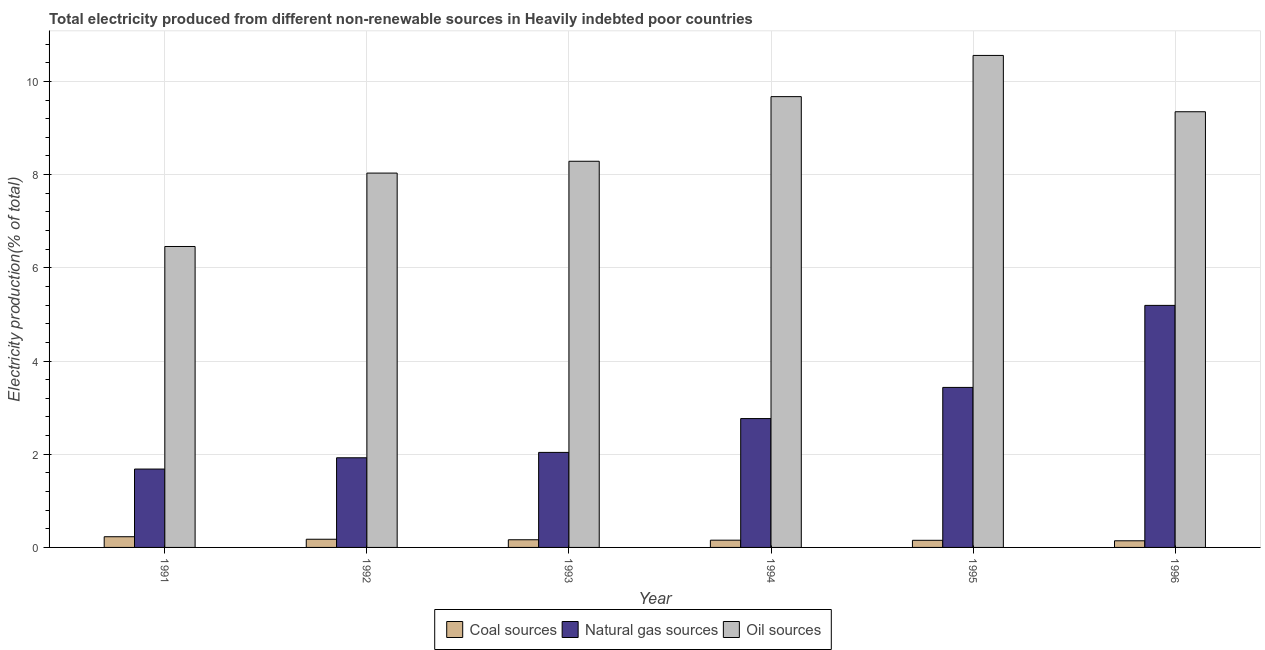Are the number of bars per tick equal to the number of legend labels?
Your answer should be very brief. Yes. Are the number of bars on each tick of the X-axis equal?
Offer a very short reply. Yes. How many bars are there on the 5th tick from the right?
Make the answer very short. 3. What is the label of the 6th group of bars from the left?
Ensure brevity in your answer.  1996. What is the percentage of electricity produced by natural gas in 1996?
Give a very brief answer. 5.19. Across all years, what is the maximum percentage of electricity produced by coal?
Ensure brevity in your answer.  0.23. Across all years, what is the minimum percentage of electricity produced by coal?
Offer a terse response. 0.14. In which year was the percentage of electricity produced by oil sources minimum?
Keep it short and to the point. 1991. What is the total percentage of electricity produced by natural gas in the graph?
Make the answer very short. 17.04. What is the difference between the percentage of electricity produced by natural gas in 1993 and that in 1996?
Your response must be concise. -3.15. What is the difference between the percentage of electricity produced by natural gas in 1993 and the percentage of electricity produced by oil sources in 1995?
Keep it short and to the point. -1.39. What is the average percentage of electricity produced by natural gas per year?
Your response must be concise. 2.84. In the year 1996, what is the difference between the percentage of electricity produced by natural gas and percentage of electricity produced by oil sources?
Offer a terse response. 0. In how many years, is the percentage of electricity produced by natural gas greater than 4.8 %?
Your answer should be compact. 1. What is the ratio of the percentage of electricity produced by coal in 1991 to that in 1996?
Offer a very short reply. 1.61. Is the difference between the percentage of electricity produced by coal in 1991 and 1995 greater than the difference between the percentage of electricity produced by natural gas in 1991 and 1995?
Provide a succinct answer. No. What is the difference between the highest and the second highest percentage of electricity produced by oil sources?
Provide a short and direct response. 0.88. What is the difference between the highest and the lowest percentage of electricity produced by oil sources?
Give a very brief answer. 4.1. What does the 2nd bar from the left in 1992 represents?
Offer a terse response. Natural gas sources. What does the 3rd bar from the right in 1993 represents?
Keep it short and to the point. Coal sources. Is it the case that in every year, the sum of the percentage of electricity produced by coal and percentage of electricity produced by natural gas is greater than the percentage of electricity produced by oil sources?
Make the answer very short. No. How many bars are there?
Make the answer very short. 18. Are the values on the major ticks of Y-axis written in scientific E-notation?
Make the answer very short. No. Does the graph contain any zero values?
Offer a very short reply. No. Does the graph contain grids?
Your answer should be compact. Yes. Where does the legend appear in the graph?
Give a very brief answer. Bottom center. What is the title of the graph?
Offer a terse response. Total electricity produced from different non-renewable sources in Heavily indebted poor countries. What is the label or title of the X-axis?
Your response must be concise. Year. What is the label or title of the Y-axis?
Ensure brevity in your answer.  Electricity production(% of total). What is the Electricity production(% of total) in Coal sources in 1991?
Provide a short and direct response. 0.23. What is the Electricity production(% of total) of Natural gas sources in 1991?
Make the answer very short. 1.68. What is the Electricity production(% of total) in Oil sources in 1991?
Offer a terse response. 6.46. What is the Electricity production(% of total) of Coal sources in 1992?
Ensure brevity in your answer.  0.18. What is the Electricity production(% of total) in Natural gas sources in 1992?
Offer a very short reply. 1.92. What is the Electricity production(% of total) of Oil sources in 1992?
Provide a short and direct response. 8.03. What is the Electricity production(% of total) of Coal sources in 1993?
Make the answer very short. 0.16. What is the Electricity production(% of total) of Natural gas sources in 1993?
Offer a very short reply. 2.04. What is the Electricity production(% of total) of Oil sources in 1993?
Make the answer very short. 8.29. What is the Electricity production(% of total) in Coal sources in 1994?
Your answer should be very brief. 0.16. What is the Electricity production(% of total) in Natural gas sources in 1994?
Ensure brevity in your answer.  2.76. What is the Electricity production(% of total) of Oil sources in 1994?
Ensure brevity in your answer.  9.67. What is the Electricity production(% of total) in Coal sources in 1995?
Your answer should be very brief. 0.15. What is the Electricity production(% of total) in Natural gas sources in 1995?
Provide a short and direct response. 3.43. What is the Electricity production(% of total) of Oil sources in 1995?
Ensure brevity in your answer.  10.56. What is the Electricity production(% of total) in Coal sources in 1996?
Provide a short and direct response. 0.14. What is the Electricity production(% of total) of Natural gas sources in 1996?
Your answer should be very brief. 5.19. What is the Electricity production(% of total) of Oil sources in 1996?
Keep it short and to the point. 9.35. Across all years, what is the maximum Electricity production(% of total) in Coal sources?
Make the answer very short. 0.23. Across all years, what is the maximum Electricity production(% of total) of Natural gas sources?
Offer a terse response. 5.19. Across all years, what is the maximum Electricity production(% of total) in Oil sources?
Make the answer very short. 10.56. Across all years, what is the minimum Electricity production(% of total) in Coal sources?
Your response must be concise. 0.14. Across all years, what is the minimum Electricity production(% of total) in Natural gas sources?
Your answer should be very brief. 1.68. Across all years, what is the minimum Electricity production(% of total) in Oil sources?
Provide a short and direct response. 6.46. What is the total Electricity production(% of total) in Coal sources in the graph?
Make the answer very short. 1.02. What is the total Electricity production(% of total) of Natural gas sources in the graph?
Your answer should be compact. 17.04. What is the total Electricity production(% of total) of Oil sources in the graph?
Provide a short and direct response. 52.35. What is the difference between the Electricity production(% of total) in Coal sources in 1991 and that in 1992?
Give a very brief answer. 0.05. What is the difference between the Electricity production(% of total) in Natural gas sources in 1991 and that in 1992?
Provide a succinct answer. -0.24. What is the difference between the Electricity production(% of total) of Oil sources in 1991 and that in 1992?
Offer a very short reply. -1.57. What is the difference between the Electricity production(% of total) of Coal sources in 1991 and that in 1993?
Your response must be concise. 0.07. What is the difference between the Electricity production(% of total) in Natural gas sources in 1991 and that in 1993?
Provide a short and direct response. -0.36. What is the difference between the Electricity production(% of total) of Oil sources in 1991 and that in 1993?
Offer a terse response. -1.83. What is the difference between the Electricity production(% of total) in Coal sources in 1991 and that in 1994?
Offer a very short reply. 0.07. What is the difference between the Electricity production(% of total) in Natural gas sources in 1991 and that in 1994?
Provide a short and direct response. -1.08. What is the difference between the Electricity production(% of total) of Oil sources in 1991 and that in 1994?
Your response must be concise. -3.22. What is the difference between the Electricity production(% of total) in Coal sources in 1991 and that in 1995?
Provide a short and direct response. 0.08. What is the difference between the Electricity production(% of total) of Natural gas sources in 1991 and that in 1995?
Make the answer very short. -1.75. What is the difference between the Electricity production(% of total) in Oil sources in 1991 and that in 1995?
Offer a terse response. -4.1. What is the difference between the Electricity production(% of total) in Coal sources in 1991 and that in 1996?
Keep it short and to the point. 0.09. What is the difference between the Electricity production(% of total) in Natural gas sources in 1991 and that in 1996?
Give a very brief answer. -3.51. What is the difference between the Electricity production(% of total) of Oil sources in 1991 and that in 1996?
Offer a very short reply. -2.89. What is the difference between the Electricity production(% of total) in Coal sources in 1992 and that in 1993?
Provide a short and direct response. 0.01. What is the difference between the Electricity production(% of total) of Natural gas sources in 1992 and that in 1993?
Provide a succinct answer. -0.12. What is the difference between the Electricity production(% of total) in Oil sources in 1992 and that in 1993?
Make the answer very short. -0.25. What is the difference between the Electricity production(% of total) of Coal sources in 1992 and that in 1994?
Your answer should be compact. 0.02. What is the difference between the Electricity production(% of total) of Natural gas sources in 1992 and that in 1994?
Ensure brevity in your answer.  -0.84. What is the difference between the Electricity production(% of total) in Oil sources in 1992 and that in 1994?
Your response must be concise. -1.64. What is the difference between the Electricity production(% of total) in Coal sources in 1992 and that in 1995?
Your response must be concise. 0.02. What is the difference between the Electricity production(% of total) of Natural gas sources in 1992 and that in 1995?
Your response must be concise. -1.51. What is the difference between the Electricity production(% of total) in Oil sources in 1992 and that in 1995?
Your answer should be compact. -2.52. What is the difference between the Electricity production(% of total) in Coal sources in 1992 and that in 1996?
Ensure brevity in your answer.  0.03. What is the difference between the Electricity production(% of total) in Natural gas sources in 1992 and that in 1996?
Offer a terse response. -3.27. What is the difference between the Electricity production(% of total) in Oil sources in 1992 and that in 1996?
Your response must be concise. -1.32. What is the difference between the Electricity production(% of total) of Coal sources in 1993 and that in 1994?
Your answer should be compact. 0.01. What is the difference between the Electricity production(% of total) in Natural gas sources in 1993 and that in 1994?
Offer a very short reply. -0.73. What is the difference between the Electricity production(% of total) of Oil sources in 1993 and that in 1994?
Give a very brief answer. -1.39. What is the difference between the Electricity production(% of total) in Coal sources in 1993 and that in 1995?
Offer a terse response. 0.01. What is the difference between the Electricity production(% of total) of Natural gas sources in 1993 and that in 1995?
Make the answer very short. -1.39. What is the difference between the Electricity production(% of total) in Oil sources in 1993 and that in 1995?
Your answer should be compact. -2.27. What is the difference between the Electricity production(% of total) in Coal sources in 1993 and that in 1996?
Offer a very short reply. 0.02. What is the difference between the Electricity production(% of total) in Natural gas sources in 1993 and that in 1996?
Keep it short and to the point. -3.15. What is the difference between the Electricity production(% of total) in Oil sources in 1993 and that in 1996?
Offer a very short reply. -1.06. What is the difference between the Electricity production(% of total) of Coal sources in 1994 and that in 1995?
Keep it short and to the point. 0. What is the difference between the Electricity production(% of total) in Natural gas sources in 1994 and that in 1995?
Keep it short and to the point. -0.67. What is the difference between the Electricity production(% of total) in Oil sources in 1994 and that in 1995?
Offer a very short reply. -0.88. What is the difference between the Electricity production(% of total) in Coal sources in 1994 and that in 1996?
Make the answer very short. 0.01. What is the difference between the Electricity production(% of total) in Natural gas sources in 1994 and that in 1996?
Provide a short and direct response. -2.43. What is the difference between the Electricity production(% of total) of Oil sources in 1994 and that in 1996?
Your answer should be very brief. 0.32. What is the difference between the Electricity production(% of total) in Coal sources in 1995 and that in 1996?
Ensure brevity in your answer.  0.01. What is the difference between the Electricity production(% of total) in Natural gas sources in 1995 and that in 1996?
Give a very brief answer. -1.76. What is the difference between the Electricity production(% of total) in Oil sources in 1995 and that in 1996?
Provide a succinct answer. 1.21. What is the difference between the Electricity production(% of total) in Coal sources in 1991 and the Electricity production(% of total) in Natural gas sources in 1992?
Your answer should be very brief. -1.69. What is the difference between the Electricity production(% of total) in Coal sources in 1991 and the Electricity production(% of total) in Oil sources in 1992?
Make the answer very short. -7.8. What is the difference between the Electricity production(% of total) in Natural gas sources in 1991 and the Electricity production(% of total) in Oil sources in 1992?
Keep it short and to the point. -6.35. What is the difference between the Electricity production(% of total) of Coal sources in 1991 and the Electricity production(% of total) of Natural gas sources in 1993?
Keep it short and to the point. -1.81. What is the difference between the Electricity production(% of total) in Coal sources in 1991 and the Electricity production(% of total) in Oil sources in 1993?
Provide a short and direct response. -8.06. What is the difference between the Electricity production(% of total) in Natural gas sources in 1991 and the Electricity production(% of total) in Oil sources in 1993?
Make the answer very short. -6.6. What is the difference between the Electricity production(% of total) in Coal sources in 1991 and the Electricity production(% of total) in Natural gas sources in 1994?
Provide a short and direct response. -2.54. What is the difference between the Electricity production(% of total) in Coal sources in 1991 and the Electricity production(% of total) in Oil sources in 1994?
Provide a succinct answer. -9.44. What is the difference between the Electricity production(% of total) in Natural gas sources in 1991 and the Electricity production(% of total) in Oil sources in 1994?
Offer a terse response. -7.99. What is the difference between the Electricity production(% of total) of Coal sources in 1991 and the Electricity production(% of total) of Natural gas sources in 1995?
Make the answer very short. -3.2. What is the difference between the Electricity production(% of total) in Coal sources in 1991 and the Electricity production(% of total) in Oil sources in 1995?
Your answer should be compact. -10.33. What is the difference between the Electricity production(% of total) of Natural gas sources in 1991 and the Electricity production(% of total) of Oil sources in 1995?
Provide a succinct answer. -8.88. What is the difference between the Electricity production(% of total) of Coal sources in 1991 and the Electricity production(% of total) of Natural gas sources in 1996?
Your answer should be very brief. -4.96. What is the difference between the Electricity production(% of total) of Coal sources in 1991 and the Electricity production(% of total) of Oil sources in 1996?
Give a very brief answer. -9.12. What is the difference between the Electricity production(% of total) of Natural gas sources in 1991 and the Electricity production(% of total) of Oil sources in 1996?
Offer a terse response. -7.67. What is the difference between the Electricity production(% of total) in Coal sources in 1992 and the Electricity production(% of total) in Natural gas sources in 1993?
Keep it short and to the point. -1.86. What is the difference between the Electricity production(% of total) in Coal sources in 1992 and the Electricity production(% of total) in Oil sources in 1993?
Make the answer very short. -8.11. What is the difference between the Electricity production(% of total) in Natural gas sources in 1992 and the Electricity production(% of total) in Oil sources in 1993?
Keep it short and to the point. -6.36. What is the difference between the Electricity production(% of total) of Coal sources in 1992 and the Electricity production(% of total) of Natural gas sources in 1994?
Make the answer very short. -2.59. What is the difference between the Electricity production(% of total) of Coal sources in 1992 and the Electricity production(% of total) of Oil sources in 1994?
Offer a very short reply. -9.5. What is the difference between the Electricity production(% of total) in Natural gas sources in 1992 and the Electricity production(% of total) in Oil sources in 1994?
Offer a very short reply. -7.75. What is the difference between the Electricity production(% of total) of Coal sources in 1992 and the Electricity production(% of total) of Natural gas sources in 1995?
Make the answer very short. -3.26. What is the difference between the Electricity production(% of total) in Coal sources in 1992 and the Electricity production(% of total) in Oil sources in 1995?
Provide a succinct answer. -10.38. What is the difference between the Electricity production(% of total) of Natural gas sources in 1992 and the Electricity production(% of total) of Oil sources in 1995?
Offer a terse response. -8.63. What is the difference between the Electricity production(% of total) in Coal sources in 1992 and the Electricity production(% of total) in Natural gas sources in 1996?
Keep it short and to the point. -5.02. What is the difference between the Electricity production(% of total) of Coal sources in 1992 and the Electricity production(% of total) of Oil sources in 1996?
Ensure brevity in your answer.  -9.17. What is the difference between the Electricity production(% of total) of Natural gas sources in 1992 and the Electricity production(% of total) of Oil sources in 1996?
Your answer should be very brief. -7.42. What is the difference between the Electricity production(% of total) in Coal sources in 1993 and the Electricity production(% of total) in Natural gas sources in 1994?
Offer a very short reply. -2.6. What is the difference between the Electricity production(% of total) of Coal sources in 1993 and the Electricity production(% of total) of Oil sources in 1994?
Ensure brevity in your answer.  -9.51. What is the difference between the Electricity production(% of total) in Natural gas sources in 1993 and the Electricity production(% of total) in Oil sources in 1994?
Keep it short and to the point. -7.63. What is the difference between the Electricity production(% of total) in Coal sources in 1993 and the Electricity production(% of total) in Natural gas sources in 1995?
Provide a short and direct response. -3.27. What is the difference between the Electricity production(% of total) in Coal sources in 1993 and the Electricity production(% of total) in Oil sources in 1995?
Your response must be concise. -10.39. What is the difference between the Electricity production(% of total) of Natural gas sources in 1993 and the Electricity production(% of total) of Oil sources in 1995?
Give a very brief answer. -8.52. What is the difference between the Electricity production(% of total) of Coal sources in 1993 and the Electricity production(% of total) of Natural gas sources in 1996?
Give a very brief answer. -5.03. What is the difference between the Electricity production(% of total) of Coal sources in 1993 and the Electricity production(% of total) of Oil sources in 1996?
Provide a succinct answer. -9.18. What is the difference between the Electricity production(% of total) of Natural gas sources in 1993 and the Electricity production(% of total) of Oil sources in 1996?
Offer a terse response. -7.31. What is the difference between the Electricity production(% of total) in Coal sources in 1994 and the Electricity production(% of total) in Natural gas sources in 1995?
Ensure brevity in your answer.  -3.28. What is the difference between the Electricity production(% of total) in Coal sources in 1994 and the Electricity production(% of total) in Oil sources in 1995?
Give a very brief answer. -10.4. What is the difference between the Electricity production(% of total) of Natural gas sources in 1994 and the Electricity production(% of total) of Oil sources in 1995?
Make the answer very short. -7.79. What is the difference between the Electricity production(% of total) in Coal sources in 1994 and the Electricity production(% of total) in Natural gas sources in 1996?
Provide a succinct answer. -5.04. What is the difference between the Electricity production(% of total) of Coal sources in 1994 and the Electricity production(% of total) of Oil sources in 1996?
Ensure brevity in your answer.  -9.19. What is the difference between the Electricity production(% of total) of Natural gas sources in 1994 and the Electricity production(% of total) of Oil sources in 1996?
Offer a very short reply. -6.58. What is the difference between the Electricity production(% of total) in Coal sources in 1995 and the Electricity production(% of total) in Natural gas sources in 1996?
Your answer should be very brief. -5.04. What is the difference between the Electricity production(% of total) in Coal sources in 1995 and the Electricity production(% of total) in Oil sources in 1996?
Provide a short and direct response. -9.2. What is the difference between the Electricity production(% of total) in Natural gas sources in 1995 and the Electricity production(% of total) in Oil sources in 1996?
Make the answer very short. -5.91. What is the average Electricity production(% of total) of Coal sources per year?
Your answer should be compact. 0.17. What is the average Electricity production(% of total) of Natural gas sources per year?
Offer a very short reply. 2.84. What is the average Electricity production(% of total) in Oil sources per year?
Provide a succinct answer. 8.73. In the year 1991, what is the difference between the Electricity production(% of total) of Coal sources and Electricity production(% of total) of Natural gas sources?
Offer a terse response. -1.45. In the year 1991, what is the difference between the Electricity production(% of total) of Coal sources and Electricity production(% of total) of Oil sources?
Your answer should be compact. -6.23. In the year 1991, what is the difference between the Electricity production(% of total) in Natural gas sources and Electricity production(% of total) in Oil sources?
Your answer should be compact. -4.78. In the year 1992, what is the difference between the Electricity production(% of total) in Coal sources and Electricity production(% of total) in Natural gas sources?
Your answer should be compact. -1.75. In the year 1992, what is the difference between the Electricity production(% of total) in Coal sources and Electricity production(% of total) in Oil sources?
Give a very brief answer. -7.86. In the year 1992, what is the difference between the Electricity production(% of total) in Natural gas sources and Electricity production(% of total) in Oil sources?
Offer a terse response. -6.11. In the year 1993, what is the difference between the Electricity production(% of total) in Coal sources and Electricity production(% of total) in Natural gas sources?
Make the answer very short. -1.87. In the year 1993, what is the difference between the Electricity production(% of total) in Coal sources and Electricity production(% of total) in Oil sources?
Your response must be concise. -8.12. In the year 1993, what is the difference between the Electricity production(% of total) in Natural gas sources and Electricity production(% of total) in Oil sources?
Provide a short and direct response. -6.25. In the year 1994, what is the difference between the Electricity production(% of total) of Coal sources and Electricity production(% of total) of Natural gas sources?
Make the answer very short. -2.61. In the year 1994, what is the difference between the Electricity production(% of total) in Coal sources and Electricity production(% of total) in Oil sources?
Offer a terse response. -9.52. In the year 1994, what is the difference between the Electricity production(% of total) in Natural gas sources and Electricity production(% of total) in Oil sources?
Make the answer very short. -6.91. In the year 1995, what is the difference between the Electricity production(% of total) of Coal sources and Electricity production(% of total) of Natural gas sources?
Offer a terse response. -3.28. In the year 1995, what is the difference between the Electricity production(% of total) in Coal sources and Electricity production(% of total) in Oil sources?
Provide a short and direct response. -10.4. In the year 1995, what is the difference between the Electricity production(% of total) of Natural gas sources and Electricity production(% of total) of Oil sources?
Your answer should be compact. -7.12. In the year 1996, what is the difference between the Electricity production(% of total) of Coal sources and Electricity production(% of total) of Natural gas sources?
Give a very brief answer. -5.05. In the year 1996, what is the difference between the Electricity production(% of total) in Coal sources and Electricity production(% of total) in Oil sources?
Your response must be concise. -9.21. In the year 1996, what is the difference between the Electricity production(% of total) of Natural gas sources and Electricity production(% of total) of Oil sources?
Make the answer very short. -4.15. What is the ratio of the Electricity production(% of total) of Coal sources in 1991 to that in 1992?
Provide a short and direct response. 1.31. What is the ratio of the Electricity production(% of total) of Natural gas sources in 1991 to that in 1992?
Make the answer very short. 0.87. What is the ratio of the Electricity production(% of total) of Oil sources in 1991 to that in 1992?
Your answer should be compact. 0.8. What is the ratio of the Electricity production(% of total) of Coal sources in 1991 to that in 1993?
Offer a terse response. 1.39. What is the ratio of the Electricity production(% of total) in Natural gas sources in 1991 to that in 1993?
Provide a succinct answer. 0.82. What is the ratio of the Electricity production(% of total) of Oil sources in 1991 to that in 1993?
Offer a very short reply. 0.78. What is the ratio of the Electricity production(% of total) in Coal sources in 1991 to that in 1994?
Make the answer very short. 1.48. What is the ratio of the Electricity production(% of total) of Natural gas sources in 1991 to that in 1994?
Keep it short and to the point. 0.61. What is the ratio of the Electricity production(% of total) in Oil sources in 1991 to that in 1994?
Offer a very short reply. 0.67. What is the ratio of the Electricity production(% of total) in Coal sources in 1991 to that in 1995?
Offer a very short reply. 1.5. What is the ratio of the Electricity production(% of total) in Natural gas sources in 1991 to that in 1995?
Offer a very short reply. 0.49. What is the ratio of the Electricity production(% of total) in Oil sources in 1991 to that in 1995?
Ensure brevity in your answer.  0.61. What is the ratio of the Electricity production(% of total) in Coal sources in 1991 to that in 1996?
Your answer should be very brief. 1.61. What is the ratio of the Electricity production(% of total) in Natural gas sources in 1991 to that in 1996?
Give a very brief answer. 0.32. What is the ratio of the Electricity production(% of total) in Oil sources in 1991 to that in 1996?
Keep it short and to the point. 0.69. What is the ratio of the Electricity production(% of total) in Coal sources in 1992 to that in 1993?
Offer a very short reply. 1.07. What is the ratio of the Electricity production(% of total) in Natural gas sources in 1992 to that in 1993?
Your answer should be compact. 0.94. What is the ratio of the Electricity production(% of total) in Oil sources in 1992 to that in 1993?
Keep it short and to the point. 0.97. What is the ratio of the Electricity production(% of total) in Coal sources in 1992 to that in 1994?
Your answer should be compact. 1.13. What is the ratio of the Electricity production(% of total) of Natural gas sources in 1992 to that in 1994?
Make the answer very short. 0.7. What is the ratio of the Electricity production(% of total) of Oil sources in 1992 to that in 1994?
Your answer should be very brief. 0.83. What is the ratio of the Electricity production(% of total) of Coal sources in 1992 to that in 1995?
Your response must be concise. 1.15. What is the ratio of the Electricity production(% of total) in Natural gas sources in 1992 to that in 1995?
Your answer should be very brief. 0.56. What is the ratio of the Electricity production(% of total) of Oil sources in 1992 to that in 1995?
Your answer should be compact. 0.76. What is the ratio of the Electricity production(% of total) in Coal sources in 1992 to that in 1996?
Provide a short and direct response. 1.23. What is the ratio of the Electricity production(% of total) of Natural gas sources in 1992 to that in 1996?
Make the answer very short. 0.37. What is the ratio of the Electricity production(% of total) in Oil sources in 1992 to that in 1996?
Provide a short and direct response. 0.86. What is the ratio of the Electricity production(% of total) of Coal sources in 1993 to that in 1994?
Ensure brevity in your answer.  1.06. What is the ratio of the Electricity production(% of total) of Natural gas sources in 1993 to that in 1994?
Your answer should be compact. 0.74. What is the ratio of the Electricity production(% of total) of Oil sources in 1993 to that in 1994?
Keep it short and to the point. 0.86. What is the ratio of the Electricity production(% of total) of Coal sources in 1993 to that in 1995?
Offer a very short reply. 1.08. What is the ratio of the Electricity production(% of total) of Natural gas sources in 1993 to that in 1995?
Offer a very short reply. 0.59. What is the ratio of the Electricity production(% of total) of Oil sources in 1993 to that in 1995?
Offer a very short reply. 0.78. What is the ratio of the Electricity production(% of total) in Coal sources in 1993 to that in 1996?
Provide a succinct answer. 1.16. What is the ratio of the Electricity production(% of total) of Natural gas sources in 1993 to that in 1996?
Your answer should be very brief. 0.39. What is the ratio of the Electricity production(% of total) of Oil sources in 1993 to that in 1996?
Provide a succinct answer. 0.89. What is the ratio of the Electricity production(% of total) in Coal sources in 1994 to that in 1995?
Keep it short and to the point. 1.02. What is the ratio of the Electricity production(% of total) in Natural gas sources in 1994 to that in 1995?
Keep it short and to the point. 0.81. What is the ratio of the Electricity production(% of total) of Oil sources in 1994 to that in 1995?
Offer a very short reply. 0.92. What is the ratio of the Electricity production(% of total) in Coal sources in 1994 to that in 1996?
Your answer should be compact. 1.09. What is the ratio of the Electricity production(% of total) of Natural gas sources in 1994 to that in 1996?
Your answer should be compact. 0.53. What is the ratio of the Electricity production(% of total) in Oil sources in 1994 to that in 1996?
Your answer should be very brief. 1.03. What is the ratio of the Electricity production(% of total) in Coal sources in 1995 to that in 1996?
Ensure brevity in your answer.  1.07. What is the ratio of the Electricity production(% of total) in Natural gas sources in 1995 to that in 1996?
Offer a very short reply. 0.66. What is the ratio of the Electricity production(% of total) of Oil sources in 1995 to that in 1996?
Keep it short and to the point. 1.13. What is the difference between the highest and the second highest Electricity production(% of total) in Coal sources?
Your answer should be very brief. 0.05. What is the difference between the highest and the second highest Electricity production(% of total) of Natural gas sources?
Keep it short and to the point. 1.76. What is the difference between the highest and the second highest Electricity production(% of total) in Oil sources?
Your response must be concise. 0.88. What is the difference between the highest and the lowest Electricity production(% of total) in Coal sources?
Make the answer very short. 0.09. What is the difference between the highest and the lowest Electricity production(% of total) of Natural gas sources?
Give a very brief answer. 3.51. What is the difference between the highest and the lowest Electricity production(% of total) in Oil sources?
Provide a succinct answer. 4.1. 